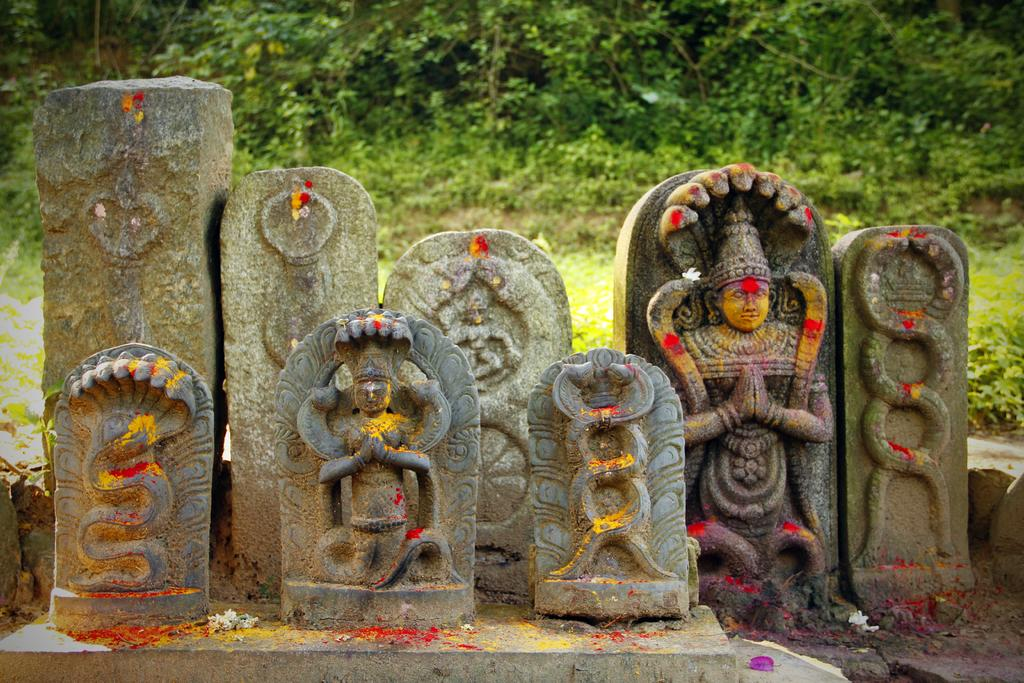What type of art is present in the image? There are sculptures in the image. What can be seen in the background of the image? There are trees visible in the background of the image. What type of farming equipment is visible in the image? There is no farming equipment present in the image. What division of labor is depicted in the image? There is no depiction of labor division in the image. 